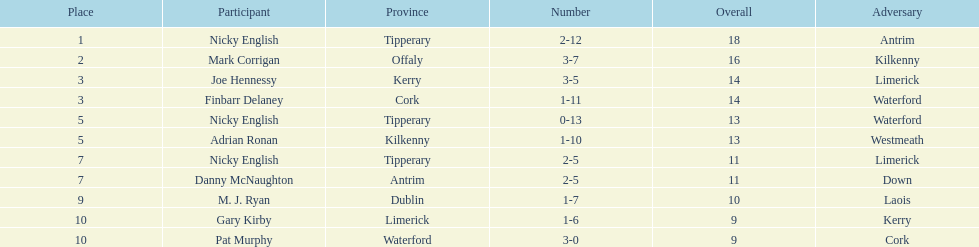What is the least total on the list? 9. Would you be able to parse every entry in this table? {'header': ['Place', 'Participant', 'Province', 'Number', 'Overall', 'Adversary'], 'rows': [['1', 'Nicky English', 'Tipperary', '2-12', '18', 'Antrim'], ['2', 'Mark Corrigan', 'Offaly', '3-7', '16', 'Kilkenny'], ['3', 'Joe Hennessy', 'Kerry', '3-5', '14', 'Limerick'], ['3', 'Finbarr Delaney', 'Cork', '1-11', '14', 'Waterford'], ['5', 'Nicky English', 'Tipperary', '0-13', '13', 'Waterford'], ['5', 'Adrian Ronan', 'Kilkenny', '1-10', '13', 'Westmeath'], ['7', 'Nicky English', 'Tipperary', '2-5', '11', 'Limerick'], ['7', 'Danny McNaughton', 'Antrim', '2-5', '11', 'Down'], ['9', 'M. J. Ryan', 'Dublin', '1-7', '10', 'Laois'], ['10', 'Gary Kirby', 'Limerick', '1-6', '9', 'Kerry'], ['10', 'Pat Murphy', 'Waterford', '3-0', '9', 'Cork']]} 